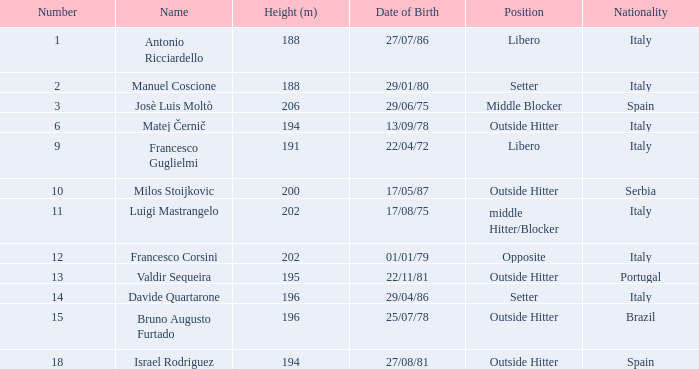Parse the table in full. {'header': ['Number', 'Name', 'Height (m)', 'Date of Birth', 'Position', 'Nationality'], 'rows': [['1', 'Antonio Ricciardello', '188', '27/07/86', 'Libero', 'Italy'], ['2', 'Manuel Coscione', '188', '29/01/80', 'Setter', 'Italy'], ['3', 'Josè Luis Moltò', '206', '29/06/75', 'Middle Blocker', 'Spain'], ['6', 'Matej Černič', '194', '13/09/78', 'Outside Hitter', 'Italy'], ['9', 'Francesco Guglielmi', '191', '22/04/72', 'Libero', 'Italy'], ['10', 'Milos Stoijkovic', '200', '17/05/87', 'Outside Hitter', 'Serbia'], ['11', 'Luigi Mastrangelo', '202', '17/08/75', 'middle Hitter/Blocker', 'Italy'], ['12', 'Francesco Corsini', '202', '01/01/79', 'Opposite', 'Italy'], ['13', 'Valdir Sequeira', '195', '22/11/81', 'Outside Hitter', 'Portugal'], ['14', 'Davide Quartarone', '196', '29/04/86', 'Setter', 'Italy'], ['15', 'Bruno Augusto Furtado', '196', '25/07/78', 'Outside Hitter', 'Brazil'], ['18', 'Israel Rodriguez', '194', '27/08/81', 'Outside Hitter', 'Spain']]} Name the nationality for francesco guglielmi Italy. 